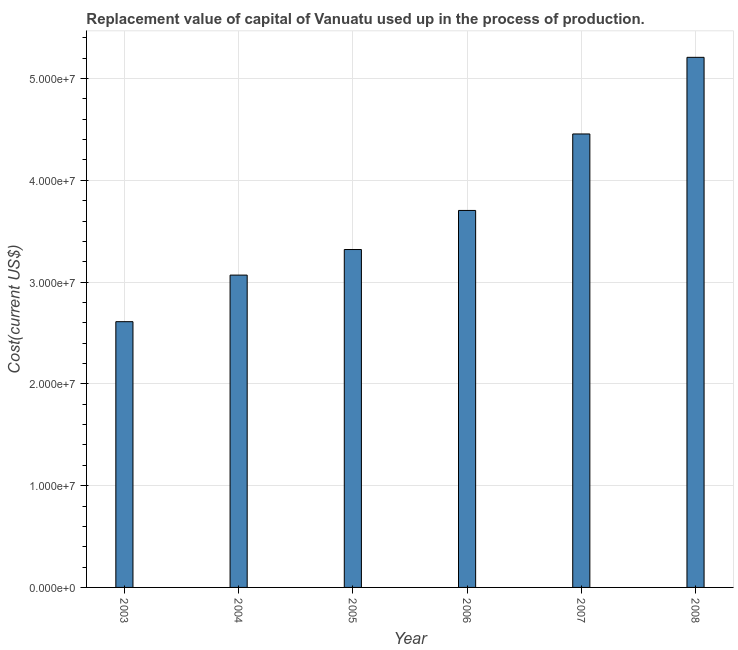Does the graph contain any zero values?
Give a very brief answer. No. What is the title of the graph?
Your answer should be compact. Replacement value of capital of Vanuatu used up in the process of production. What is the label or title of the X-axis?
Your answer should be very brief. Year. What is the label or title of the Y-axis?
Your answer should be compact. Cost(current US$). What is the consumption of fixed capital in 2008?
Offer a very short reply. 5.21e+07. Across all years, what is the maximum consumption of fixed capital?
Offer a terse response. 5.21e+07. Across all years, what is the minimum consumption of fixed capital?
Ensure brevity in your answer.  2.61e+07. In which year was the consumption of fixed capital maximum?
Keep it short and to the point. 2008. What is the sum of the consumption of fixed capital?
Provide a short and direct response. 2.24e+08. What is the difference between the consumption of fixed capital in 2005 and 2007?
Provide a short and direct response. -1.14e+07. What is the average consumption of fixed capital per year?
Your answer should be very brief. 3.73e+07. What is the median consumption of fixed capital?
Keep it short and to the point. 3.51e+07. In how many years, is the consumption of fixed capital greater than 38000000 US$?
Your answer should be compact. 2. What is the ratio of the consumption of fixed capital in 2006 to that in 2008?
Your answer should be very brief. 0.71. What is the difference between the highest and the second highest consumption of fixed capital?
Ensure brevity in your answer.  7.53e+06. What is the difference between the highest and the lowest consumption of fixed capital?
Your response must be concise. 2.60e+07. Are all the bars in the graph horizontal?
Make the answer very short. No. What is the difference between two consecutive major ticks on the Y-axis?
Provide a short and direct response. 1.00e+07. What is the Cost(current US$) in 2003?
Give a very brief answer. 2.61e+07. What is the Cost(current US$) in 2004?
Offer a very short reply. 3.07e+07. What is the Cost(current US$) of 2005?
Ensure brevity in your answer.  3.32e+07. What is the Cost(current US$) in 2006?
Provide a succinct answer. 3.70e+07. What is the Cost(current US$) of 2007?
Provide a succinct answer. 4.46e+07. What is the Cost(current US$) of 2008?
Your response must be concise. 5.21e+07. What is the difference between the Cost(current US$) in 2003 and 2004?
Your response must be concise. -4.58e+06. What is the difference between the Cost(current US$) in 2003 and 2005?
Make the answer very short. -7.09e+06. What is the difference between the Cost(current US$) in 2003 and 2006?
Give a very brief answer. -1.09e+07. What is the difference between the Cost(current US$) in 2003 and 2007?
Offer a terse response. -1.84e+07. What is the difference between the Cost(current US$) in 2003 and 2008?
Keep it short and to the point. -2.60e+07. What is the difference between the Cost(current US$) in 2004 and 2005?
Make the answer very short. -2.51e+06. What is the difference between the Cost(current US$) in 2004 and 2006?
Give a very brief answer. -6.35e+06. What is the difference between the Cost(current US$) in 2004 and 2007?
Ensure brevity in your answer.  -1.39e+07. What is the difference between the Cost(current US$) in 2004 and 2008?
Your response must be concise. -2.14e+07. What is the difference between the Cost(current US$) in 2005 and 2006?
Provide a short and direct response. -3.84e+06. What is the difference between the Cost(current US$) in 2005 and 2007?
Keep it short and to the point. -1.14e+07. What is the difference between the Cost(current US$) in 2005 and 2008?
Offer a terse response. -1.89e+07. What is the difference between the Cost(current US$) in 2006 and 2007?
Offer a terse response. -7.51e+06. What is the difference between the Cost(current US$) in 2006 and 2008?
Your answer should be very brief. -1.50e+07. What is the difference between the Cost(current US$) in 2007 and 2008?
Keep it short and to the point. -7.53e+06. What is the ratio of the Cost(current US$) in 2003 to that in 2004?
Provide a short and direct response. 0.85. What is the ratio of the Cost(current US$) in 2003 to that in 2005?
Make the answer very short. 0.79. What is the ratio of the Cost(current US$) in 2003 to that in 2006?
Your answer should be compact. 0.7. What is the ratio of the Cost(current US$) in 2003 to that in 2007?
Offer a very short reply. 0.59. What is the ratio of the Cost(current US$) in 2003 to that in 2008?
Ensure brevity in your answer.  0.5. What is the ratio of the Cost(current US$) in 2004 to that in 2005?
Keep it short and to the point. 0.92. What is the ratio of the Cost(current US$) in 2004 to that in 2006?
Your response must be concise. 0.83. What is the ratio of the Cost(current US$) in 2004 to that in 2007?
Your response must be concise. 0.69. What is the ratio of the Cost(current US$) in 2004 to that in 2008?
Your answer should be very brief. 0.59. What is the ratio of the Cost(current US$) in 2005 to that in 2006?
Ensure brevity in your answer.  0.9. What is the ratio of the Cost(current US$) in 2005 to that in 2007?
Your answer should be compact. 0.74. What is the ratio of the Cost(current US$) in 2005 to that in 2008?
Keep it short and to the point. 0.64. What is the ratio of the Cost(current US$) in 2006 to that in 2007?
Your response must be concise. 0.83. What is the ratio of the Cost(current US$) in 2006 to that in 2008?
Provide a succinct answer. 0.71. What is the ratio of the Cost(current US$) in 2007 to that in 2008?
Your response must be concise. 0.85. 